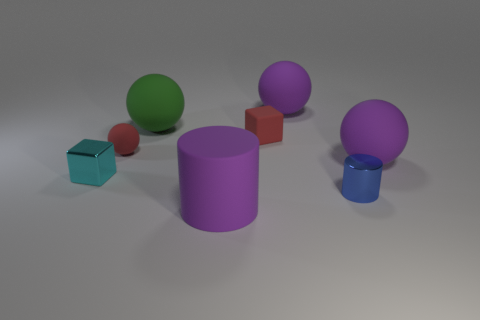Add 1 large purple rubber cylinders. How many objects exist? 9 Subtract all cylinders. How many objects are left? 6 Subtract 0 green cubes. How many objects are left? 8 Subtract all big green things. Subtract all small cyan objects. How many objects are left? 6 Add 7 tiny rubber balls. How many tiny rubber balls are left? 8 Add 5 small shiny balls. How many small shiny balls exist? 5 